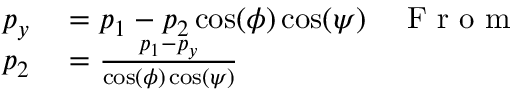Convert formula to latex. <formula><loc_0><loc_0><loc_500><loc_500>\begin{array} { r l r } { p _ { y } } & = p _ { 1 } - p _ { 2 } \cos ( \phi ) \cos ( \psi ) } & { F r o m } \\ { p _ { 2 } } & = \frac { p _ { 1 } - p _ { y } } { \cos ( \phi ) \cos ( \psi ) } } \end{array}</formula> 